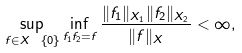<formula> <loc_0><loc_0><loc_500><loc_500>\sup _ { f \in X \ \left \{ 0 \right \} } \inf _ { f _ { 1 } f _ { 2 } = f } \frac { \| f _ { 1 } \| _ { X _ { 1 } } \| f _ { 2 } \| _ { X _ { 2 } } } { \| f \| _ { X } } < \infty ,</formula> 